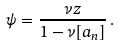Convert formula to latex. <formula><loc_0><loc_0><loc_500><loc_500>\psi = \frac { \nu z } { 1 - \nu [ a _ { n } ] } \, .</formula> 